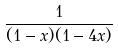<formula> <loc_0><loc_0><loc_500><loc_500>\frac { 1 } { ( 1 - x ) ( 1 - 4 x ) }</formula> 